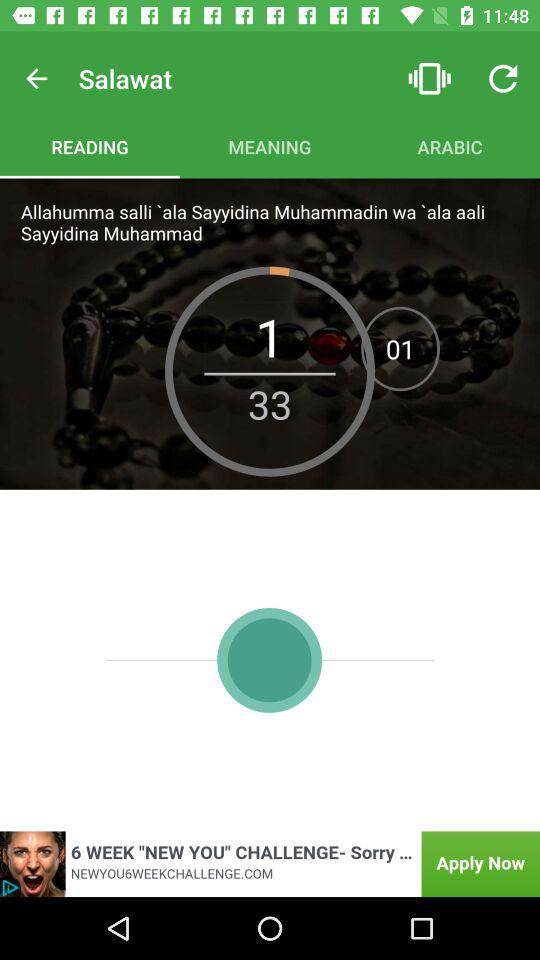Which tab is selected? The selected tab is "READING". 